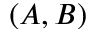Convert formula to latex. <formula><loc_0><loc_0><loc_500><loc_500>( A , B )</formula> 